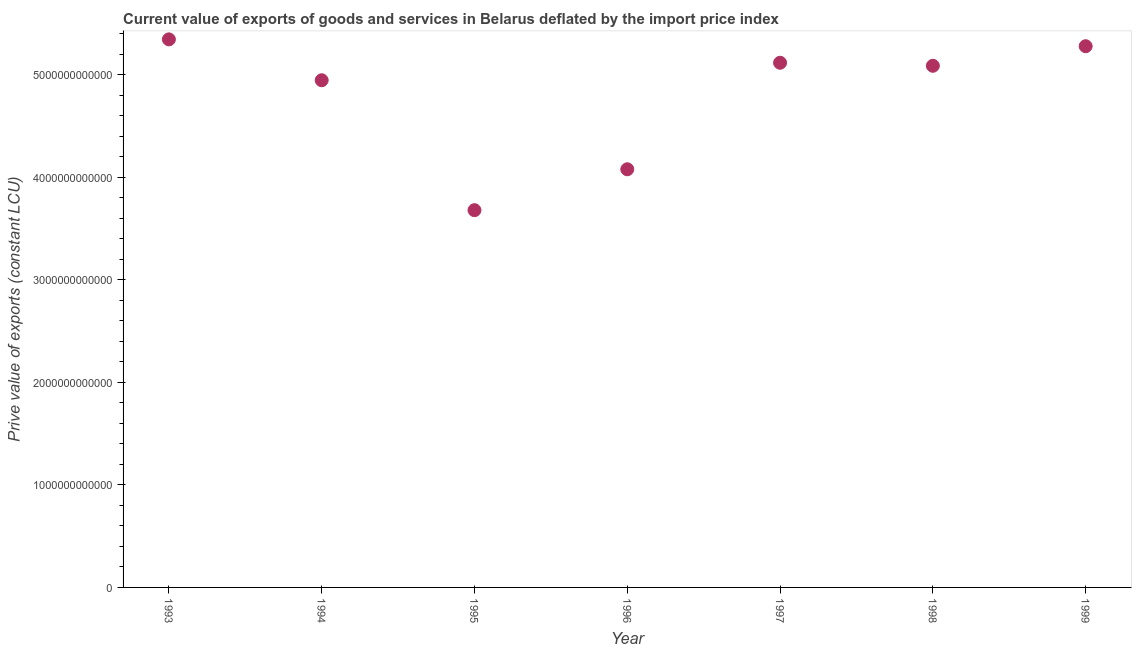What is the price value of exports in 1999?
Give a very brief answer. 5.28e+12. Across all years, what is the maximum price value of exports?
Your answer should be compact. 5.34e+12. Across all years, what is the minimum price value of exports?
Provide a succinct answer. 3.68e+12. What is the sum of the price value of exports?
Make the answer very short. 3.35e+13. What is the difference between the price value of exports in 1994 and 1996?
Your response must be concise. 8.68e+11. What is the average price value of exports per year?
Give a very brief answer. 4.79e+12. What is the median price value of exports?
Offer a terse response. 5.09e+12. In how many years, is the price value of exports greater than 4800000000000 LCU?
Offer a terse response. 5. What is the ratio of the price value of exports in 1993 to that in 1998?
Offer a terse response. 1.05. Is the price value of exports in 1993 less than that in 1996?
Ensure brevity in your answer.  No. What is the difference between the highest and the second highest price value of exports?
Give a very brief answer. 6.68e+1. Is the sum of the price value of exports in 1994 and 1995 greater than the maximum price value of exports across all years?
Your answer should be very brief. Yes. What is the difference between the highest and the lowest price value of exports?
Your response must be concise. 1.67e+12. Does the price value of exports monotonically increase over the years?
Offer a very short reply. No. How many dotlines are there?
Keep it short and to the point. 1. What is the difference between two consecutive major ticks on the Y-axis?
Offer a terse response. 1.00e+12. Are the values on the major ticks of Y-axis written in scientific E-notation?
Make the answer very short. No. Does the graph contain any zero values?
Offer a very short reply. No. Does the graph contain grids?
Give a very brief answer. No. What is the title of the graph?
Your answer should be compact. Current value of exports of goods and services in Belarus deflated by the import price index. What is the label or title of the X-axis?
Your response must be concise. Year. What is the label or title of the Y-axis?
Your answer should be compact. Prive value of exports (constant LCU). What is the Prive value of exports (constant LCU) in 1993?
Offer a very short reply. 5.34e+12. What is the Prive value of exports (constant LCU) in 1994?
Offer a terse response. 4.95e+12. What is the Prive value of exports (constant LCU) in 1995?
Your answer should be very brief. 3.68e+12. What is the Prive value of exports (constant LCU) in 1996?
Ensure brevity in your answer.  4.08e+12. What is the Prive value of exports (constant LCU) in 1997?
Give a very brief answer. 5.12e+12. What is the Prive value of exports (constant LCU) in 1998?
Provide a succinct answer. 5.09e+12. What is the Prive value of exports (constant LCU) in 1999?
Keep it short and to the point. 5.28e+12. What is the difference between the Prive value of exports (constant LCU) in 1993 and 1994?
Provide a succinct answer. 3.99e+11. What is the difference between the Prive value of exports (constant LCU) in 1993 and 1995?
Make the answer very short. 1.67e+12. What is the difference between the Prive value of exports (constant LCU) in 1993 and 1996?
Provide a succinct answer. 1.27e+12. What is the difference between the Prive value of exports (constant LCU) in 1993 and 1997?
Ensure brevity in your answer.  2.28e+11. What is the difference between the Prive value of exports (constant LCU) in 1993 and 1998?
Your answer should be compact. 2.58e+11. What is the difference between the Prive value of exports (constant LCU) in 1993 and 1999?
Your response must be concise. 6.68e+1. What is the difference between the Prive value of exports (constant LCU) in 1994 and 1995?
Ensure brevity in your answer.  1.27e+12. What is the difference between the Prive value of exports (constant LCU) in 1994 and 1996?
Offer a terse response. 8.68e+11. What is the difference between the Prive value of exports (constant LCU) in 1994 and 1997?
Keep it short and to the point. -1.71e+11. What is the difference between the Prive value of exports (constant LCU) in 1994 and 1998?
Ensure brevity in your answer.  -1.41e+11. What is the difference between the Prive value of exports (constant LCU) in 1994 and 1999?
Give a very brief answer. -3.32e+11. What is the difference between the Prive value of exports (constant LCU) in 1995 and 1996?
Offer a terse response. -3.99e+11. What is the difference between the Prive value of exports (constant LCU) in 1995 and 1997?
Ensure brevity in your answer.  -1.44e+12. What is the difference between the Prive value of exports (constant LCU) in 1995 and 1998?
Make the answer very short. -1.41e+12. What is the difference between the Prive value of exports (constant LCU) in 1995 and 1999?
Provide a short and direct response. -1.60e+12. What is the difference between the Prive value of exports (constant LCU) in 1996 and 1997?
Keep it short and to the point. -1.04e+12. What is the difference between the Prive value of exports (constant LCU) in 1996 and 1998?
Provide a succinct answer. -1.01e+12. What is the difference between the Prive value of exports (constant LCU) in 1996 and 1999?
Make the answer very short. -1.20e+12. What is the difference between the Prive value of exports (constant LCU) in 1997 and 1998?
Your answer should be compact. 2.95e+1. What is the difference between the Prive value of exports (constant LCU) in 1997 and 1999?
Keep it short and to the point. -1.61e+11. What is the difference between the Prive value of exports (constant LCU) in 1998 and 1999?
Make the answer very short. -1.91e+11. What is the ratio of the Prive value of exports (constant LCU) in 1993 to that in 1994?
Make the answer very short. 1.08. What is the ratio of the Prive value of exports (constant LCU) in 1993 to that in 1995?
Your answer should be compact. 1.45. What is the ratio of the Prive value of exports (constant LCU) in 1993 to that in 1996?
Ensure brevity in your answer.  1.31. What is the ratio of the Prive value of exports (constant LCU) in 1993 to that in 1997?
Keep it short and to the point. 1.04. What is the ratio of the Prive value of exports (constant LCU) in 1993 to that in 1998?
Make the answer very short. 1.05. What is the ratio of the Prive value of exports (constant LCU) in 1993 to that in 1999?
Your answer should be very brief. 1.01. What is the ratio of the Prive value of exports (constant LCU) in 1994 to that in 1995?
Your answer should be very brief. 1.34. What is the ratio of the Prive value of exports (constant LCU) in 1994 to that in 1996?
Make the answer very short. 1.21. What is the ratio of the Prive value of exports (constant LCU) in 1994 to that in 1997?
Provide a short and direct response. 0.97. What is the ratio of the Prive value of exports (constant LCU) in 1994 to that in 1998?
Your answer should be compact. 0.97. What is the ratio of the Prive value of exports (constant LCU) in 1994 to that in 1999?
Make the answer very short. 0.94. What is the ratio of the Prive value of exports (constant LCU) in 1995 to that in 1996?
Your answer should be very brief. 0.9. What is the ratio of the Prive value of exports (constant LCU) in 1995 to that in 1997?
Keep it short and to the point. 0.72. What is the ratio of the Prive value of exports (constant LCU) in 1995 to that in 1998?
Offer a terse response. 0.72. What is the ratio of the Prive value of exports (constant LCU) in 1995 to that in 1999?
Ensure brevity in your answer.  0.7. What is the ratio of the Prive value of exports (constant LCU) in 1996 to that in 1997?
Provide a short and direct response. 0.8. What is the ratio of the Prive value of exports (constant LCU) in 1996 to that in 1998?
Offer a very short reply. 0.8. What is the ratio of the Prive value of exports (constant LCU) in 1996 to that in 1999?
Your response must be concise. 0.77. What is the ratio of the Prive value of exports (constant LCU) in 1997 to that in 1998?
Ensure brevity in your answer.  1.01. What is the ratio of the Prive value of exports (constant LCU) in 1997 to that in 1999?
Give a very brief answer. 0.97. What is the ratio of the Prive value of exports (constant LCU) in 1998 to that in 1999?
Give a very brief answer. 0.96. 